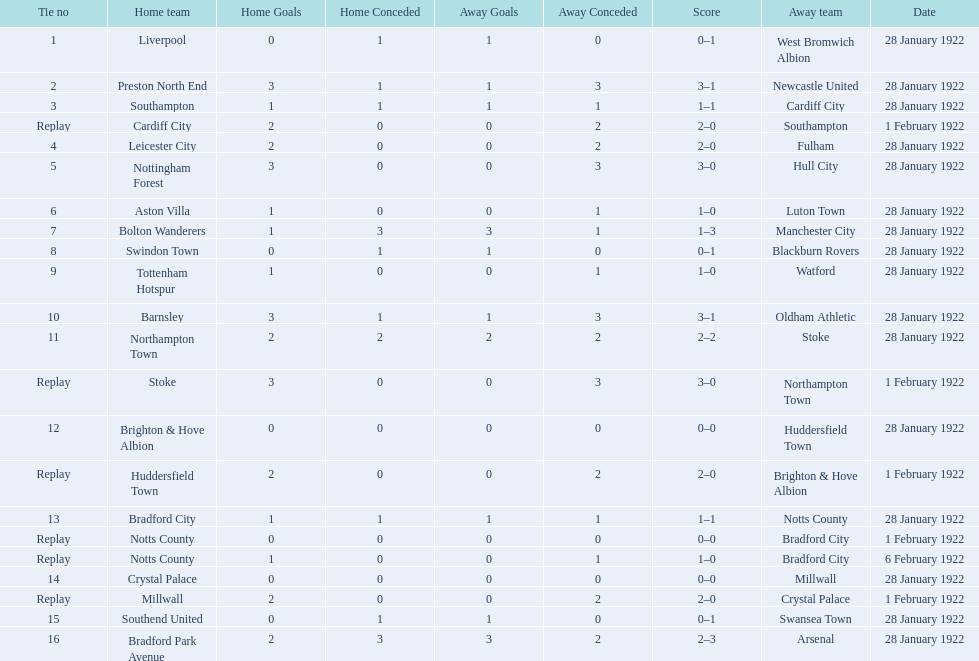Which team had a score of 0-1? Liverpool. Which team had a replay? Cardiff City. Which team had the same score as aston villa? Tottenham Hotspur. 